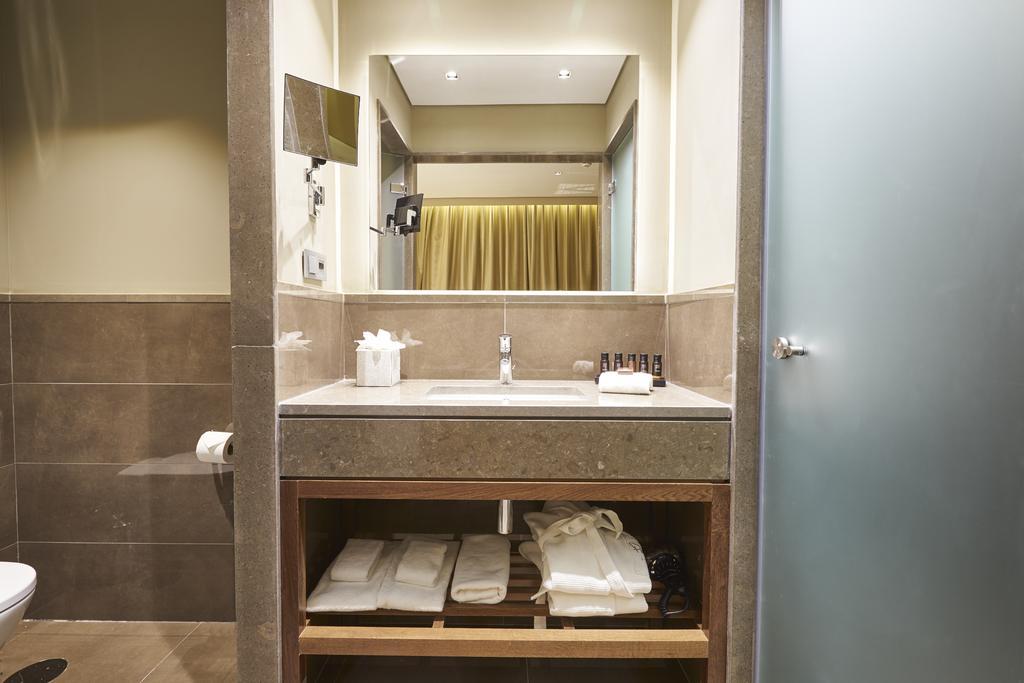Describe this image in one or two sentences. In the center of the image there is a wall, tissue paper, bowl toilet, sink, tap, door, mirrors, towels and a few other objects. In the mirrors, we can see the reflection of some objects. 